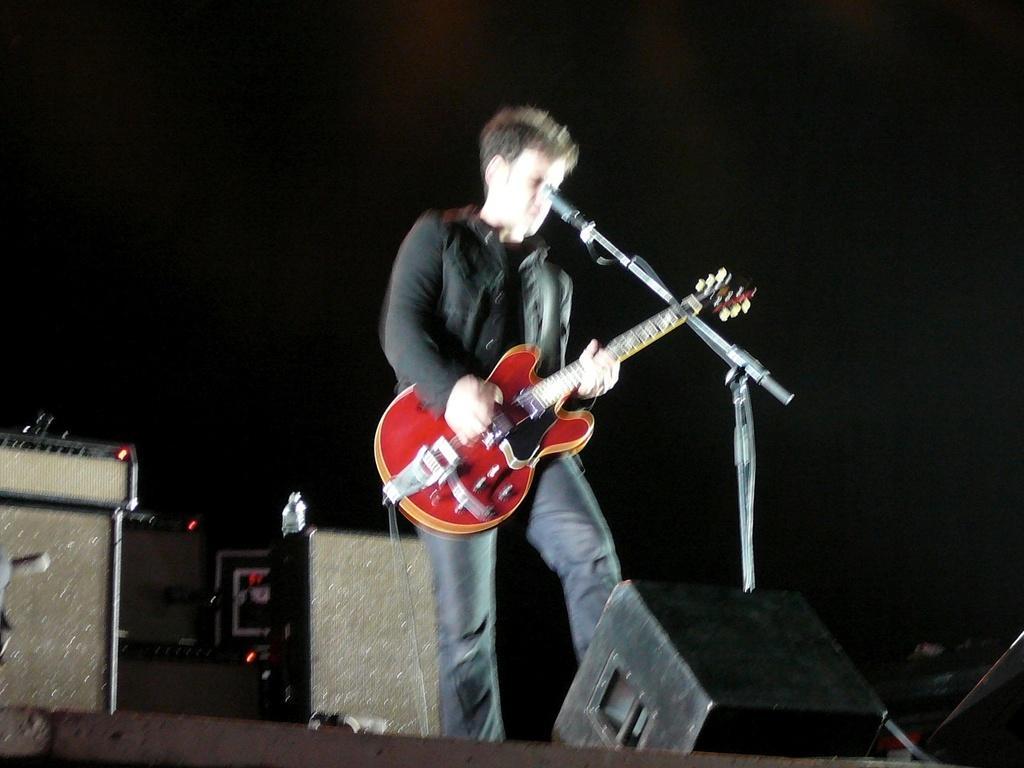In one or two sentences, can you explain what this image depicts? The background of the picture is very dark. These are the devices. Here we can see one man standing and playing a guitar. He wore black jacket. This is amike. 